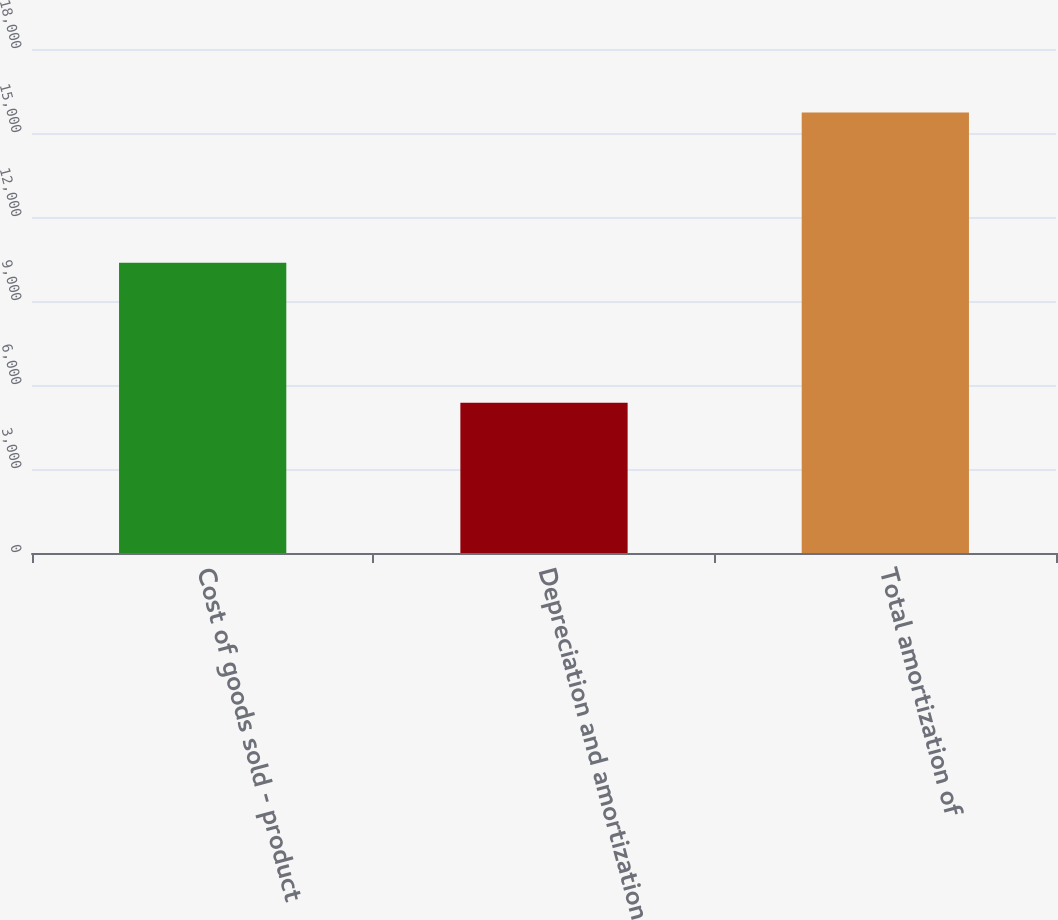Convert chart to OTSL. <chart><loc_0><loc_0><loc_500><loc_500><bar_chart><fcel>Cost of goods sold - product<fcel>Depreciation and amortization<fcel>Total amortization of<nl><fcel>10364<fcel>5365<fcel>15729<nl></chart> 